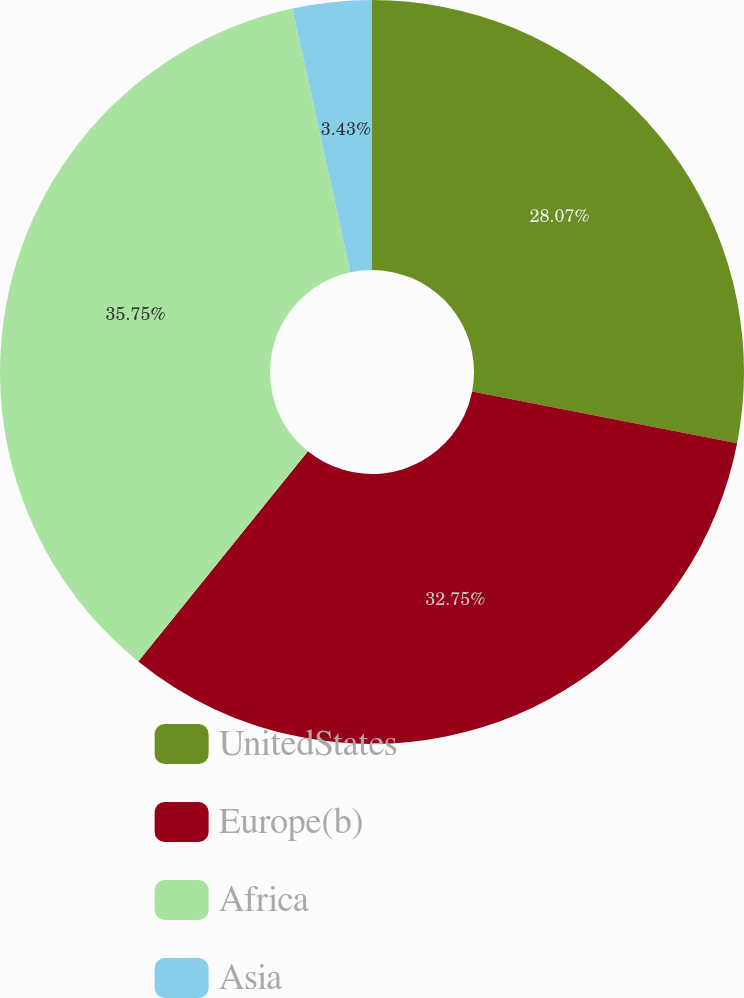Convert chart. <chart><loc_0><loc_0><loc_500><loc_500><pie_chart><fcel>UnitedStates<fcel>Europe(b)<fcel>Africa<fcel>Asia<nl><fcel>28.07%<fcel>32.75%<fcel>35.76%<fcel>3.43%<nl></chart> 